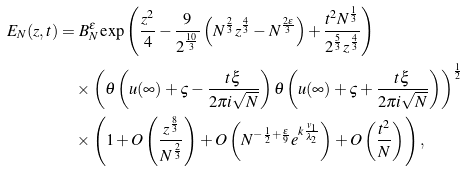Convert formula to latex. <formula><loc_0><loc_0><loc_500><loc_500>E _ { N } ( z , t ) & = B _ { N } ^ { \epsilon } \exp \left ( \frac { z ^ { 2 } } { 4 } - \frac { 9 } { 2 ^ { \frac { 1 0 } { 3 } } } \left ( N ^ { \frac { 2 } { 3 } } z ^ { \frac { 4 } { 3 } } - N ^ { \frac { 2 \epsilon } { 3 } } \right ) + \frac { t ^ { 2 } N ^ { \frac { 1 } { 3 } } } { 2 ^ { \frac { 5 } { 3 } } z ^ { \frac { 4 } { 3 } } } \right ) \\ & \quad \times \left ( \theta \left ( u ( \infty ) + \varsigma - \frac { t \xi } { 2 \pi i \sqrt { N } } \right ) \theta \left ( u ( \infty ) + \varsigma + \frac { t \xi } { 2 \pi i \sqrt { N } } \right ) \right ) ^ { \frac { 1 } { 2 } } \\ & \quad \times \left ( 1 + O \left ( \frac { z ^ { \frac { 8 } { 3 } } } { N ^ { \frac { 2 } { 3 } } } \right ) + O \left ( N ^ { - \frac { 1 } { 2 } + \frac { \epsilon } { 9 } } e ^ { k \frac { v _ { 1 } } { \lambda _ { 2 } } } \right ) + O \left ( \frac { t ^ { 2 } } { N } \right ) \right ) ,</formula> 